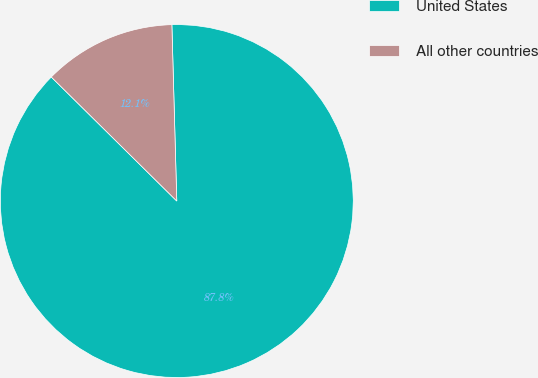<chart> <loc_0><loc_0><loc_500><loc_500><pie_chart><fcel>United States<fcel>All other countries<nl><fcel>87.85%<fcel>12.15%<nl></chart> 